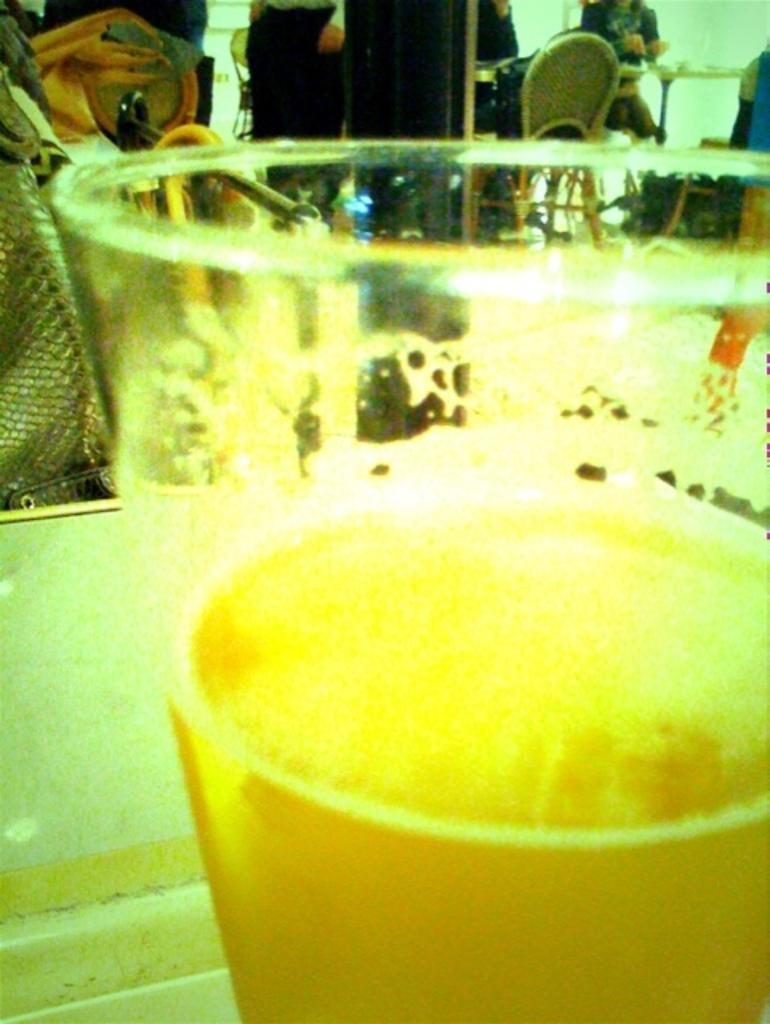What can be seen in the image that is used for holding a beverage? There is a beverage glass in the image. What are the persons in the image doing? The persons in the image are sitting on chairs. What type of silk fabric is draped over the persons' shoulders in the image? There is no silk fabric present in the image; the persons are simply sitting on chairs. 